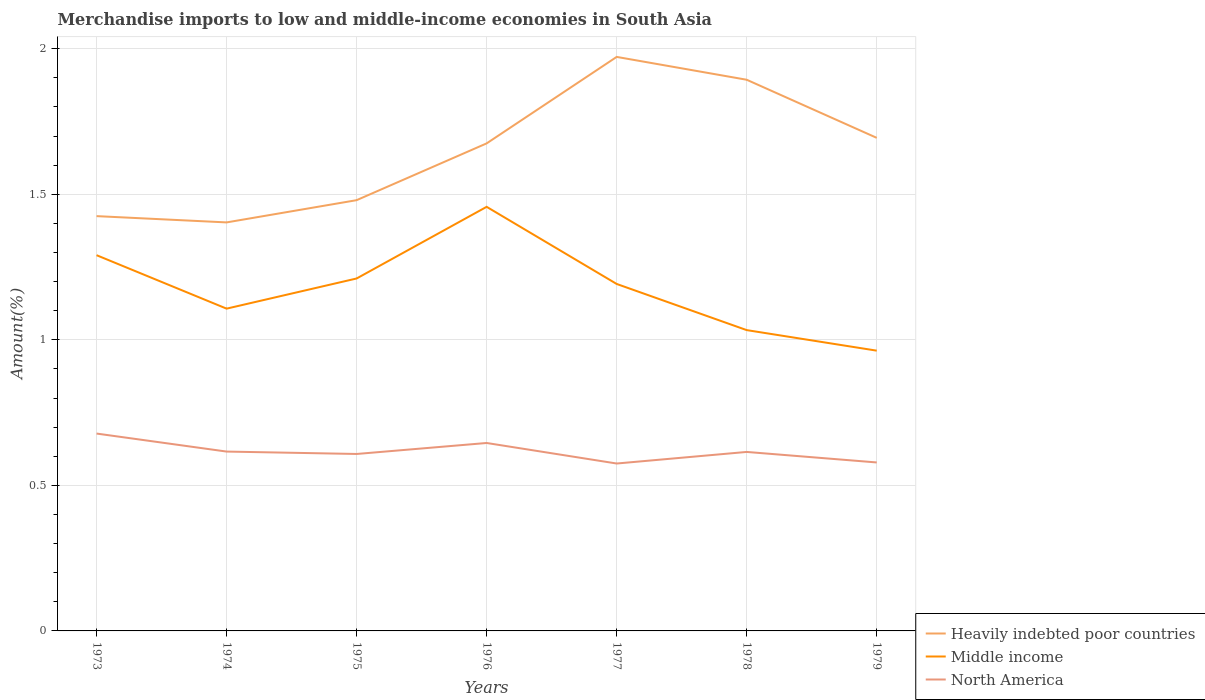Is the number of lines equal to the number of legend labels?
Keep it short and to the point. Yes. Across all years, what is the maximum percentage of amount earned from merchandise imports in Heavily indebted poor countries?
Your response must be concise. 1.4. What is the total percentage of amount earned from merchandise imports in Middle income in the graph?
Ensure brevity in your answer.  0.42. What is the difference between the highest and the second highest percentage of amount earned from merchandise imports in North America?
Your answer should be very brief. 0.1. What is the difference between the highest and the lowest percentage of amount earned from merchandise imports in Heavily indebted poor countries?
Ensure brevity in your answer.  4. How many lines are there?
Your answer should be very brief. 3. Are the values on the major ticks of Y-axis written in scientific E-notation?
Keep it short and to the point. No. Does the graph contain any zero values?
Provide a short and direct response. No. Where does the legend appear in the graph?
Ensure brevity in your answer.  Bottom right. How are the legend labels stacked?
Your answer should be very brief. Vertical. What is the title of the graph?
Ensure brevity in your answer.  Merchandise imports to low and middle-income economies in South Asia. Does "High income: nonOECD" appear as one of the legend labels in the graph?
Offer a very short reply. No. What is the label or title of the X-axis?
Ensure brevity in your answer.  Years. What is the label or title of the Y-axis?
Ensure brevity in your answer.  Amount(%). What is the Amount(%) in Heavily indebted poor countries in 1973?
Your response must be concise. 1.42. What is the Amount(%) of Middle income in 1973?
Provide a short and direct response. 1.29. What is the Amount(%) in North America in 1973?
Your answer should be very brief. 0.68. What is the Amount(%) in Heavily indebted poor countries in 1974?
Make the answer very short. 1.4. What is the Amount(%) in Middle income in 1974?
Provide a short and direct response. 1.11. What is the Amount(%) in North America in 1974?
Make the answer very short. 0.62. What is the Amount(%) of Heavily indebted poor countries in 1975?
Provide a short and direct response. 1.48. What is the Amount(%) in Middle income in 1975?
Provide a succinct answer. 1.21. What is the Amount(%) in North America in 1975?
Make the answer very short. 0.61. What is the Amount(%) of Heavily indebted poor countries in 1976?
Ensure brevity in your answer.  1.67. What is the Amount(%) of Middle income in 1976?
Provide a succinct answer. 1.46. What is the Amount(%) in North America in 1976?
Ensure brevity in your answer.  0.65. What is the Amount(%) of Heavily indebted poor countries in 1977?
Keep it short and to the point. 1.97. What is the Amount(%) in Middle income in 1977?
Your answer should be compact. 1.19. What is the Amount(%) of North America in 1977?
Offer a terse response. 0.58. What is the Amount(%) of Heavily indebted poor countries in 1978?
Offer a terse response. 1.89. What is the Amount(%) in Middle income in 1978?
Ensure brevity in your answer.  1.03. What is the Amount(%) of North America in 1978?
Your answer should be compact. 0.61. What is the Amount(%) of Heavily indebted poor countries in 1979?
Provide a succinct answer. 1.69. What is the Amount(%) in Middle income in 1979?
Give a very brief answer. 0.96. What is the Amount(%) in North America in 1979?
Offer a terse response. 0.58. Across all years, what is the maximum Amount(%) in Heavily indebted poor countries?
Your response must be concise. 1.97. Across all years, what is the maximum Amount(%) of Middle income?
Your answer should be compact. 1.46. Across all years, what is the maximum Amount(%) of North America?
Your answer should be very brief. 0.68. Across all years, what is the minimum Amount(%) of Heavily indebted poor countries?
Keep it short and to the point. 1.4. Across all years, what is the minimum Amount(%) of Middle income?
Offer a very short reply. 0.96. Across all years, what is the minimum Amount(%) of North America?
Provide a succinct answer. 0.58. What is the total Amount(%) of Heavily indebted poor countries in the graph?
Keep it short and to the point. 11.54. What is the total Amount(%) in Middle income in the graph?
Make the answer very short. 8.25. What is the total Amount(%) in North America in the graph?
Your answer should be very brief. 4.32. What is the difference between the Amount(%) in Heavily indebted poor countries in 1973 and that in 1974?
Your response must be concise. 0.02. What is the difference between the Amount(%) in Middle income in 1973 and that in 1974?
Offer a terse response. 0.18. What is the difference between the Amount(%) in North America in 1973 and that in 1974?
Give a very brief answer. 0.06. What is the difference between the Amount(%) of Heavily indebted poor countries in 1973 and that in 1975?
Ensure brevity in your answer.  -0.05. What is the difference between the Amount(%) of Middle income in 1973 and that in 1975?
Your answer should be very brief. 0.08. What is the difference between the Amount(%) of North America in 1973 and that in 1975?
Provide a succinct answer. 0.07. What is the difference between the Amount(%) in Heavily indebted poor countries in 1973 and that in 1976?
Your answer should be very brief. -0.25. What is the difference between the Amount(%) in Middle income in 1973 and that in 1976?
Ensure brevity in your answer.  -0.17. What is the difference between the Amount(%) of North America in 1973 and that in 1976?
Give a very brief answer. 0.03. What is the difference between the Amount(%) in Heavily indebted poor countries in 1973 and that in 1977?
Offer a very short reply. -0.55. What is the difference between the Amount(%) of Middle income in 1973 and that in 1977?
Ensure brevity in your answer.  0.1. What is the difference between the Amount(%) in North America in 1973 and that in 1977?
Your response must be concise. 0.1. What is the difference between the Amount(%) of Heavily indebted poor countries in 1973 and that in 1978?
Keep it short and to the point. -0.47. What is the difference between the Amount(%) in Middle income in 1973 and that in 1978?
Your answer should be very brief. 0.26. What is the difference between the Amount(%) in North America in 1973 and that in 1978?
Your answer should be compact. 0.06. What is the difference between the Amount(%) of Heavily indebted poor countries in 1973 and that in 1979?
Your answer should be very brief. -0.27. What is the difference between the Amount(%) of Middle income in 1973 and that in 1979?
Keep it short and to the point. 0.33. What is the difference between the Amount(%) in North America in 1973 and that in 1979?
Your answer should be compact. 0.1. What is the difference between the Amount(%) in Heavily indebted poor countries in 1974 and that in 1975?
Provide a short and direct response. -0.08. What is the difference between the Amount(%) of Middle income in 1974 and that in 1975?
Ensure brevity in your answer.  -0.1. What is the difference between the Amount(%) of North America in 1974 and that in 1975?
Ensure brevity in your answer.  0.01. What is the difference between the Amount(%) of Heavily indebted poor countries in 1974 and that in 1976?
Make the answer very short. -0.27. What is the difference between the Amount(%) in Middle income in 1974 and that in 1976?
Ensure brevity in your answer.  -0.35. What is the difference between the Amount(%) in North America in 1974 and that in 1976?
Your answer should be compact. -0.03. What is the difference between the Amount(%) of Heavily indebted poor countries in 1974 and that in 1977?
Offer a very short reply. -0.57. What is the difference between the Amount(%) of Middle income in 1974 and that in 1977?
Your answer should be very brief. -0.08. What is the difference between the Amount(%) in North America in 1974 and that in 1977?
Make the answer very short. 0.04. What is the difference between the Amount(%) in Heavily indebted poor countries in 1974 and that in 1978?
Offer a very short reply. -0.49. What is the difference between the Amount(%) of Middle income in 1974 and that in 1978?
Keep it short and to the point. 0.07. What is the difference between the Amount(%) of North America in 1974 and that in 1978?
Offer a terse response. 0. What is the difference between the Amount(%) of Heavily indebted poor countries in 1974 and that in 1979?
Make the answer very short. -0.29. What is the difference between the Amount(%) of Middle income in 1974 and that in 1979?
Provide a short and direct response. 0.14. What is the difference between the Amount(%) in North America in 1974 and that in 1979?
Your answer should be compact. 0.04. What is the difference between the Amount(%) of Heavily indebted poor countries in 1975 and that in 1976?
Your answer should be compact. -0.2. What is the difference between the Amount(%) in Middle income in 1975 and that in 1976?
Keep it short and to the point. -0.25. What is the difference between the Amount(%) of North America in 1975 and that in 1976?
Provide a succinct answer. -0.04. What is the difference between the Amount(%) in Heavily indebted poor countries in 1975 and that in 1977?
Keep it short and to the point. -0.49. What is the difference between the Amount(%) of Middle income in 1975 and that in 1977?
Your response must be concise. 0.02. What is the difference between the Amount(%) of North America in 1975 and that in 1977?
Ensure brevity in your answer.  0.03. What is the difference between the Amount(%) of Heavily indebted poor countries in 1975 and that in 1978?
Ensure brevity in your answer.  -0.41. What is the difference between the Amount(%) in Middle income in 1975 and that in 1978?
Your answer should be very brief. 0.18. What is the difference between the Amount(%) in North America in 1975 and that in 1978?
Your answer should be very brief. -0.01. What is the difference between the Amount(%) in Heavily indebted poor countries in 1975 and that in 1979?
Make the answer very short. -0.21. What is the difference between the Amount(%) of Middle income in 1975 and that in 1979?
Provide a short and direct response. 0.25. What is the difference between the Amount(%) in North America in 1975 and that in 1979?
Ensure brevity in your answer.  0.03. What is the difference between the Amount(%) in Heavily indebted poor countries in 1976 and that in 1977?
Make the answer very short. -0.3. What is the difference between the Amount(%) of Middle income in 1976 and that in 1977?
Your response must be concise. 0.27. What is the difference between the Amount(%) of North America in 1976 and that in 1977?
Make the answer very short. 0.07. What is the difference between the Amount(%) of Heavily indebted poor countries in 1976 and that in 1978?
Ensure brevity in your answer.  -0.22. What is the difference between the Amount(%) of Middle income in 1976 and that in 1978?
Provide a succinct answer. 0.42. What is the difference between the Amount(%) of North America in 1976 and that in 1978?
Offer a terse response. 0.03. What is the difference between the Amount(%) in Heavily indebted poor countries in 1976 and that in 1979?
Your answer should be compact. -0.02. What is the difference between the Amount(%) in Middle income in 1976 and that in 1979?
Provide a short and direct response. 0.49. What is the difference between the Amount(%) of North America in 1976 and that in 1979?
Your answer should be very brief. 0.07. What is the difference between the Amount(%) in Heavily indebted poor countries in 1977 and that in 1978?
Your answer should be very brief. 0.08. What is the difference between the Amount(%) in Middle income in 1977 and that in 1978?
Offer a very short reply. 0.16. What is the difference between the Amount(%) of North America in 1977 and that in 1978?
Your response must be concise. -0.04. What is the difference between the Amount(%) of Heavily indebted poor countries in 1977 and that in 1979?
Make the answer very short. 0.28. What is the difference between the Amount(%) in Middle income in 1977 and that in 1979?
Your answer should be very brief. 0.23. What is the difference between the Amount(%) of North America in 1977 and that in 1979?
Your answer should be compact. -0. What is the difference between the Amount(%) of Heavily indebted poor countries in 1978 and that in 1979?
Your answer should be compact. 0.2. What is the difference between the Amount(%) of Middle income in 1978 and that in 1979?
Offer a terse response. 0.07. What is the difference between the Amount(%) in North America in 1978 and that in 1979?
Make the answer very short. 0.04. What is the difference between the Amount(%) of Heavily indebted poor countries in 1973 and the Amount(%) of Middle income in 1974?
Give a very brief answer. 0.32. What is the difference between the Amount(%) in Heavily indebted poor countries in 1973 and the Amount(%) in North America in 1974?
Your response must be concise. 0.81. What is the difference between the Amount(%) of Middle income in 1973 and the Amount(%) of North America in 1974?
Provide a short and direct response. 0.67. What is the difference between the Amount(%) of Heavily indebted poor countries in 1973 and the Amount(%) of Middle income in 1975?
Your response must be concise. 0.21. What is the difference between the Amount(%) of Heavily indebted poor countries in 1973 and the Amount(%) of North America in 1975?
Your response must be concise. 0.82. What is the difference between the Amount(%) of Middle income in 1973 and the Amount(%) of North America in 1975?
Provide a succinct answer. 0.68. What is the difference between the Amount(%) in Heavily indebted poor countries in 1973 and the Amount(%) in Middle income in 1976?
Provide a succinct answer. -0.03. What is the difference between the Amount(%) in Heavily indebted poor countries in 1973 and the Amount(%) in North America in 1976?
Your response must be concise. 0.78. What is the difference between the Amount(%) in Middle income in 1973 and the Amount(%) in North America in 1976?
Provide a succinct answer. 0.65. What is the difference between the Amount(%) of Heavily indebted poor countries in 1973 and the Amount(%) of Middle income in 1977?
Keep it short and to the point. 0.23. What is the difference between the Amount(%) in Heavily indebted poor countries in 1973 and the Amount(%) in North America in 1977?
Provide a short and direct response. 0.85. What is the difference between the Amount(%) of Middle income in 1973 and the Amount(%) of North America in 1977?
Provide a short and direct response. 0.72. What is the difference between the Amount(%) in Heavily indebted poor countries in 1973 and the Amount(%) in Middle income in 1978?
Give a very brief answer. 0.39. What is the difference between the Amount(%) of Heavily indebted poor countries in 1973 and the Amount(%) of North America in 1978?
Your response must be concise. 0.81. What is the difference between the Amount(%) of Middle income in 1973 and the Amount(%) of North America in 1978?
Offer a terse response. 0.68. What is the difference between the Amount(%) of Heavily indebted poor countries in 1973 and the Amount(%) of Middle income in 1979?
Offer a very short reply. 0.46. What is the difference between the Amount(%) of Heavily indebted poor countries in 1973 and the Amount(%) of North America in 1979?
Offer a terse response. 0.85. What is the difference between the Amount(%) of Middle income in 1973 and the Amount(%) of North America in 1979?
Ensure brevity in your answer.  0.71. What is the difference between the Amount(%) in Heavily indebted poor countries in 1974 and the Amount(%) in Middle income in 1975?
Your answer should be very brief. 0.19. What is the difference between the Amount(%) of Heavily indebted poor countries in 1974 and the Amount(%) of North America in 1975?
Offer a very short reply. 0.8. What is the difference between the Amount(%) of Middle income in 1974 and the Amount(%) of North America in 1975?
Provide a succinct answer. 0.5. What is the difference between the Amount(%) of Heavily indebted poor countries in 1974 and the Amount(%) of Middle income in 1976?
Your response must be concise. -0.05. What is the difference between the Amount(%) in Heavily indebted poor countries in 1974 and the Amount(%) in North America in 1976?
Your answer should be very brief. 0.76. What is the difference between the Amount(%) of Middle income in 1974 and the Amount(%) of North America in 1976?
Provide a short and direct response. 0.46. What is the difference between the Amount(%) in Heavily indebted poor countries in 1974 and the Amount(%) in Middle income in 1977?
Make the answer very short. 0.21. What is the difference between the Amount(%) in Heavily indebted poor countries in 1974 and the Amount(%) in North America in 1977?
Give a very brief answer. 0.83. What is the difference between the Amount(%) in Middle income in 1974 and the Amount(%) in North America in 1977?
Offer a terse response. 0.53. What is the difference between the Amount(%) in Heavily indebted poor countries in 1974 and the Amount(%) in Middle income in 1978?
Offer a very short reply. 0.37. What is the difference between the Amount(%) in Heavily indebted poor countries in 1974 and the Amount(%) in North America in 1978?
Provide a succinct answer. 0.79. What is the difference between the Amount(%) in Middle income in 1974 and the Amount(%) in North America in 1978?
Ensure brevity in your answer.  0.49. What is the difference between the Amount(%) in Heavily indebted poor countries in 1974 and the Amount(%) in Middle income in 1979?
Your answer should be compact. 0.44. What is the difference between the Amount(%) of Heavily indebted poor countries in 1974 and the Amount(%) of North America in 1979?
Offer a terse response. 0.82. What is the difference between the Amount(%) of Middle income in 1974 and the Amount(%) of North America in 1979?
Keep it short and to the point. 0.53. What is the difference between the Amount(%) in Heavily indebted poor countries in 1975 and the Amount(%) in Middle income in 1976?
Keep it short and to the point. 0.02. What is the difference between the Amount(%) of Heavily indebted poor countries in 1975 and the Amount(%) of North America in 1976?
Ensure brevity in your answer.  0.83. What is the difference between the Amount(%) of Middle income in 1975 and the Amount(%) of North America in 1976?
Offer a terse response. 0.57. What is the difference between the Amount(%) of Heavily indebted poor countries in 1975 and the Amount(%) of Middle income in 1977?
Give a very brief answer. 0.29. What is the difference between the Amount(%) in Heavily indebted poor countries in 1975 and the Amount(%) in North America in 1977?
Your answer should be very brief. 0.9. What is the difference between the Amount(%) of Middle income in 1975 and the Amount(%) of North America in 1977?
Make the answer very short. 0.64. What is the difference between the Amount(%) in Heavily indebted poor countries in 1975 and the Amount(%) in Middle income in 1978?
Keep it short and to the point. 0.45. What is the difference between the Amount(%) in Heavily indebted poor countries in 1975 and the Amount(%) in North America in 1978?
Provide a short and direct response. 0.86. What is the difference between the Amount(%) of Middle income in 1975 and the Amount(%) of North America in 1978?
Your answer should be compact. 0.6. What is the difference between the Amount(%) of Heavily indebted poor countries in 1975 and the Amount(%) of Middle income in 1979?
Offer a terse response. 0.52. What is the difference between the Amount(%) of Heavily indebted poor countries in 1975 and the Amount(%) of North America in 1979?
Ensure brevity in your answer.  0.9. What is the difference between the Amount(%) in Middle income in 1975 and the Amount(%) in North America in 1979?
Offer a very short reply. 0.63. What is the difference between the Amount(%) in Heavily indebted poor countries in 1976 and the Amount(%) in Middle income in 1977?
Give a very brief answer. 0.48. What is the difference between the Amount(%) in Heavily indebted poor countries in 1976 and the Amount(%) in North America in 1977?
Make the answer very short. 1.1. What is the difference between the Amount(%) in Middle income in 1976 and the Amount(%) in North America in 1977?
Your response must be concise. 0.88. What is the difference between the Amount(%) of Heavily indebted poor countries in 1976 and the Amount(%) of Middle income in 1978?
Offer a terse response. 0.64. What is the difference between the Amount(%) of Heavily indebted poor countries in 1976 and the Amount(%) of North America in 1978?
Make the answer very short. 1.06. What is the difference between the Amount(%) of Middle income in 1976 and the Amount(%) of North America in 1978?
Provide a succinct answer. 0.84. What is the difference between the Amount(%) in Heavily indebted poor countries in 1976 and the Amount(%) in Middle income in 1979?
Your response must be concise. 0.71. What is the difference between the Amount(%) in Heavily indebted poor countries in 1976 and the Amount(%) in North America in 1979?
Your response must be concise. 1.1. What is the difference between the Amount(%) of Middle income in 1976 and the Amount(%) of North America in 1979?
Ensure brevity in your answer.  0.88. What is the difference between the Amount(%) in Heavily indebted poor countries in 1977 and the Amount(%) in Middle income in 1978?
Make the answer very short. 0.94. What is the difference between the Amount(%) of Heavily indebted poor countries in 1977 and the Amount(%) of North America in 1978?
Provide a short and direct response. 1.36. What is the difference between the Amount(%) in Middle income in 1977 and the Amount(%) in North America in 1978?
Ensure brevity in your answer.  0.58. What is the difference between the Amount(%) of Heavily indebted poor countries in 1977 and the Amount(%) of Middle income in 1979?
Make the answer very short. 1.01. What is the difference between the Amount(%) of Heavily indebted poor countries in 1977 and the Amount(%) of North America in 1979?
Offer a very short reply. 1.39. What is the difference between the Amount(%) of Middle income in 1977 and the Amount(%) of North America in 1979?
Keep it short and to the point. 0.61. What is the difference between the Amount(%) of Heavily indebted poor countries in 1978 and the Amount(%) of Middle income in 1979?
Make the answer very short. 0.93. What is the difference between the Amount(%) of Heavily indebted poor countries in 1978 and the Amount(%) of North America in 1979?
Provide a succinct answer. 1.31. What is the difference between the Amount(%) of Middle income in 1978 and the Amount(%) of North America in 1979?
Offer a terse response. 0.45. What is the average Amount(%) of Heavily indebted poor countries per year?
Your response must be concise. 1.65. What is the average Amount(%) in Middle income per year?
Your answer should be compact. 1.18. What is the average Amount(%) in North America per year?
Offer a very short reply. 0.62. In the year 1973, what is the difference between the Amount(%) in Heavily indebted poor countries and Amount(%) in Middle income?
Your answer should be very brief. 0.13. In the year 1973, what is the difference between the Amount(%) in Heavily indebted poor countries and Amount(%) in North America?
Provide a succinct answer. 0.75. In the year 1973, what is the difference between the Amount(%) of Middle income and Amount(%) of North America?
Offer a terse response. 0.61. In the year 1974, what is the difference between the Amount(%) of Heavily indebted poor countries and Amount(%) of Middle income?
Give a very brief answer. 0.3. In the year 1974, what is the difference between the Amount(%) in Heavily indebted poor countries and Amount(%) in North America?
Ensure brevity in your answer.  0.79. In the year 1974, what is the difference between the Amount(%) of Middle income and Amount(%) of North America?
Give a very brief answer. 0.49. In the year 1975, what is the difference between the Amount(%) of Heavily indebted poor countries and Amount(%) of Middle income?
Ensure brevity in your answer.  0.27. In the year 1975, what is the difference between the Amount(%) of Heavily indebted poor countries and Amount(%) of North America?
Keep it short and to the point. 0.87. In the year 1975, what is the difference between the Amount(%) of Middle income and Amount(%) of North America?
Offer a terse response. 0.6. In the year 1976, what is the difference between the Amount(%) of Heavily indebted poor countries and Amount(%) of Middle income?
Provide a short and direct response. 0.22. In the year 1976, what is the difference between the Amount(%) of Heavily indebted poor countries and Amount(%) of North America?
Provide a short and direct response. 1.03. In the year 1976, what is the difference between the Amount(%) in Middle income and Amount(%) in North America?
Your response must be concise. 0.81. In the year 1977, what is the difference between the Amount(%) of Heavily indebted poor countries and Amount(%) of Middle income?
Offer a very short reply. 0.78. In the year 1977, what is the difference between the Amount(%) in Heavily indebted poor countries and Amount(%) in North America?
Offer a very short reply. 1.4. In the year 1977, what is the difference between the Amount(%) in Middle income and Amount(%) in North America?
Provide a short and direct response. 0.62. In the year 1978, what is the difference between the Amount(%) in Heavily indebted poor countries and Amount(%) in Middle income?
Offer a terse response. 0.86. In the year 1978, what is the difference between the Amount(%) in Heavily indebted poor countries and Amount(%) in North America?
Make the answer very short. 1.28. In the year 1978, what is the difference between the Amount(%) of Middle income and Amount(%) of North America?
Your answer should be very brief. 0.42. In the year 1979, what is the difference between the Amount(%) in Heavily indebted poor countries and Amount(%) in Middle income?
Offer a terse response. 0.73. In the year 1979, what is the difference between the Amount(%) in Heavily indebted poor countries and Amount(%) in North America?
Keep it short and to the point. 1.11. In the year 1979, what is the difference between the Amount(%) in Middle income and Amount(%) in North America?
Your answer should be compact. 0.38. What is the ratio of the Amount(%) of Heavily indebted poor countries in 1973 to that in 1974?
Offer a terse response. 1.02. What is the ratio of the Amount(%) in Middle income in 1973 to that in 1974?
Provide a succinct answer. 1.17. What is the ratio of the Amount(%) of North America in 1973 to that in 1974?
Offer a terse response. 1.1. What is the ratio of the Amount(%) of Middle income in 1973 to that in 1975?
Ensure brevity in your answer.  1.07. What is the ratio of the Amount(%) of North America in 1973 to that in 1975?
Provide a succinct answer. 1.12. What is the ratio of the Amount(%) of Heavily indebted poor countries in 1973 to that in 1976?
Offer a terse response. 0.85. What is the ratio of the Amount(%) in Middle income in 1973 to that in 1976?
Make the answer very short. 0.89. What is the ratio of the Amount(%) in North America in 1973 to that in 1976?
Provide a short and direct response. 1.05. What is the ratio of the Amount(%) in Heavily indebted poor countries in 1973 to that in 1977?
Your answer should be compact. 0.72. What is the ratio of the Amount(%) in Middle income in 1973 to that in 1977?
Your answer should be very brief. 1.08. What is the ratio of the Amount(%) of North America in 1973 to that in 1977?
Provide a succinct answer. 1.18. What is the ratio of the Amount(%) in Heavily indebted poor countries in 1973 to that in 1978?
Ensure brevity in your answer.  0.75. What is the ratio of the Amount(%) of Middle income in 1973 to that in 1978?
Provide a succinct answer. 1.25. What is the ratio of the Amount(%) in North America in 1973 to that in 1978?
Make the answer very short. 1.1. What is the ratio of the Amount(%) of Heavily indebted poor countries in 1973 to that in 1979?
Give a very brief answer. 0.84. What is the ratio of the Amount(%) in Middle income in 1973 to that in 1979?
Your answer should be compact. 1.34. What is the ratio of the Amount(%) in North America in 1973 to that in 1979?
Your answer should be compact. 1.17. What is the ratio of the Amount(%) of Heavily indebted poor countries in 1974 to that in 1975?
Provide a short and direct response. 0.95. What is the ratio of the Amount(%) of Middle income in 1974 to that in 1975?
Offer a very short reply. 0.91. What is the ratio of the Amount(%) in North America in 1974 to that in 1975?
Make the answer very short. 1.01. What is the ratio of the Amount(%) in Heavily indebted poor countries in 1974 to that in 1976?
Keep it short and to the point. 0.84. What is the ratio of the Amount(%) in Middle income in 1974 to that in 1976?
Your response must be concise. 0.76. What is the ratio of the Amount(%) of North America in 1974 to that in 1976?
Provide a succinct answer. 0.95. What is the ratio of the Amount(%) in Heavily indebted poor countries in 1974 to that in 1977?
Keep it short and to the point. 0.71. What is the ratio of the Amount(%) in Middle income in 1974 to that in 1977?
Your answer should be very brief. 0.93. What is the ratio of the Amount(%) in North America in 1974 to that in 1977?
Your answer should be very brief. 1.07. What is the ratio of the Amount(%) in Heavily indebted poor countries in 1974 to that in 1978?
Your answer should be very brief. 0.74. What is the ratio of the Amount(%) of Middle income in 1974 to that in 1978?
Your response must be concise. 1.07. What is the ratio of the Amount(%) in North America in 1974 to that in 1978?
Give a very brief answer. 1. What is the ratio of the Amount(%) of Heavily indebted poor countries in 1974 to that in 1979?
Your answer should be compact. 0.83. What is the ratio of the Amount(%) of Middle income in 1974 to that in 1979?
Your answer should be compact. 1.15. What is the ratio of the Amount(%) in North America in 1974 to that in 1979?
Provide a short and direct response. 1.06. What is the ratio of the Amount(%) of Heavily indebted poor countries in 1975 to that in 1976?
Ensure brevity in your answer.  0.88. What is the ratio of the Amount(%) in Middle income in 1975 to that in 1976?
Your answer should be compact. 0.83. What is the ratio of the Amount(%) in North America in 1975 to that in 1976?
Your answer should be compact. 0.94. What is the ratio of the Amount(%) of Heavily indebted poor countries in 1975 to that in 1977?
Keep it short and to the point. 0.75. What is the ratio of the Amount(%) in Middle income in 1975 to that in 1977?
Your answer should be compact. 1.02. What is the ratio of the Amount(%) in North America in 1975 to that in 1977?
Your response must be concise. 1.06. What is the ratio of the Amount(%) in Heavily indebted poor countries in 1975 to that in 1978?
Your answer should be very brief. 0.78. What is the ratio of the Amount(%) of Middle income in 1975 to that in 1978?
Your answer should be very brief. 1.17. What is the ratio of the Amount(%) of North America in 1975 to that in 1978?
Provide a succinct answer. 0.99. What is the ratio of the Amount(%) in Heavily indebted poor countries in 1975 to that in 1979?
Your answer should be very brief. 0.87. What is the ratio of the Amount(%) of Middle income in 1975 to that in 1979?
Provide a succinct answer. 1.26. What is the ratio of the Amount(%) in North America in 1975 to that in 1979?
Your response must be concise. 1.05. What is the ratio of the Amount(%) in Heavily indebted poor countries in 1976 to that in 1977?
Your answer should be very brief. 0.85. What is the ratio of the Amount(%) in Middle income in 1976 to that in 1977?
Ensure brevity in your answer.  1.22. What is the ratio of the Amount(%) of North America in 1976 to that in 1977?
Your answer should be very brief. 1.12. What is the ratio of the Amount(%) of Heavily indebted poor countries in 1976 to that in 1978?
Make the answer very short. 0.88. What is the ratio of the Amount(%) in Middle income in 1976 to that in 1978?
Your answer should be compact. 1.41. What is the ratio of the Amount(%) of Heavily indebted poor countries in 1976 to that in 1979?
Your response must be concise. 0.99. What is the ratio of the Amount(%) in Middle income in 1976 to that in 1979?
Your response must be concise. 1.51. What is the ratio of the Amount(%) in North America in 1976 to that in 1979?
Your answer should be very brief. 1.12. What is the ratio of the Amount(%) of Heavily indebted poor countries in 1977 to that in 1978?
Give a very brief answer. 1.04. What is the ratio of the Amount(%) in Middle income in 1977 to that in 1978?
Provide a succinct answer. 1.15. What is the ratio of the Amount(%) of North America in 1977 to that in 1978?
Provide a short and direct response. 0.94. What is the ratio of the Amount(%) in Heavily indebted poor countries in 1977 to that in 1979?
Your answer should be compact. 1.16. What is the ratio of the Amount(%) of Middle income in 1977 to that in 1979?
Ensure brevity in your answer.  1.24. What is the ratio of the Amount(%) of Heavily indebted poor countries in 1978 to that in 1979?
Your answer should be compact. 1.12. What is the ratio of the Amount(%) of Middle income in 1978 to that in 1979?
Give a very brief answer. 1.07. What is the ratio of the Amount(%) in North America in 1978 to that in 1979?
Offer a terse response. 1.06. What is the difference between the highest and the second highest Amount(%) of Heavily indebted poor countries?
Ensure brevity in your answer.  0.08. What is the difference between the highest and the second highest Amount(%) of Middle income?
Your response must be concise. 0.17. What is the difference between the highest and the second highest Amount(%) in North America?
Offer a terse response. 0.03. What is the difference between the highest and the lowest Amount(%) in Heavily indebted poor countries?
Your response must be concise. 0.57. What is the difference between the highest and the lowest Amount(%) in Middle income?
Your response must be concise. 0.49. What is the difference between the highest and the lowest Amount(%) of North America?
Your answer should be very brief. 0.1. 